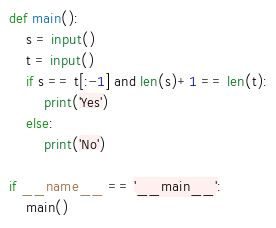<code> <loc_0><loc_0><loc_500><loc_500><_Python_>def main():
    s = input()
    t = input()
    if s == t[:-1] and len(s)+1 == len(t):
        print('Yes')
    else:
        print('No')

if __name__ == '__main__':
    main()

</code> 